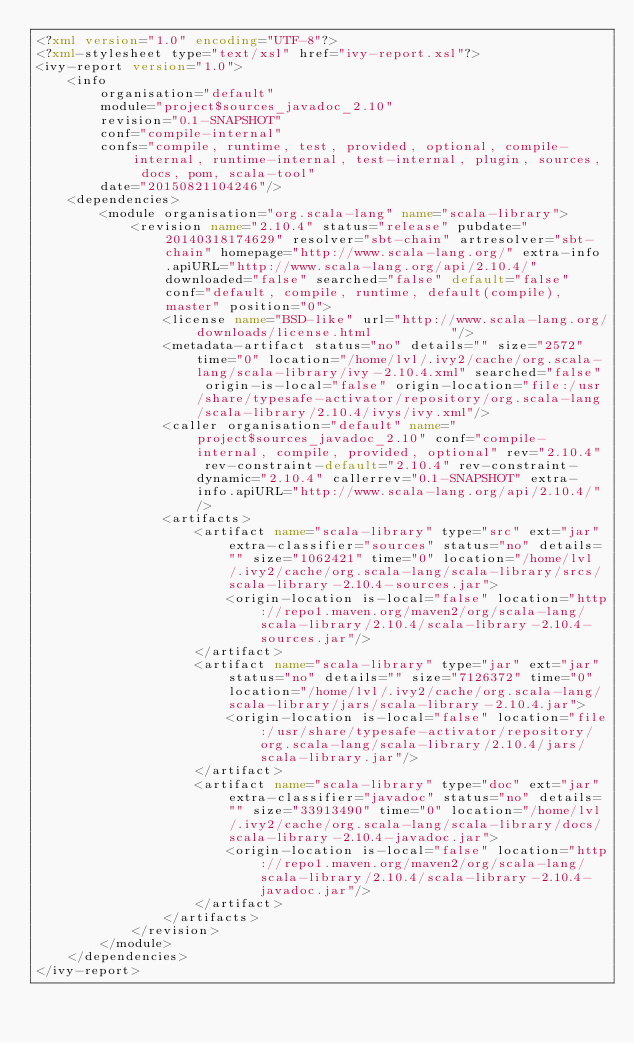<code> <loc_0><loc_0><loc_500><loc_500><_XML_><?xml version="1.0" encoding="UTF-8"?>
<?xml-stylesheet type="text/xsl" href="ivy-report.xsl"?>
<ivy-report version="1.0">
	<info
		organisation="default"
		module="project$sources_javadoc_2.10"
		revision="0.1-SNAPSHOT"
		conf="compile-internal"
		confs="compile, runtime, test, provided, optional, compile-internal, runtime-internal, test-internal, plugin, sources, docs, pom, scala-tool"
		date="20150821104246"/>
	<dependencies>
		<module organisation="org.scala-lang" name="scala-library">
			<revision name="2.10.4" status="release" pubdate="20140318174629" resolver="sbt-chain" artresolver="sbt-chain" homepage="http://www.scala-lang.org/" extra-info.apiURL="http://www.scala-lang.org/api/2.10.4/" downloaded="false" searched="false" default="false" conf="default, compile, runtime, default(compile), master" position="0">
				<license name="BSD-like" url="http://www.scala-lang.org/downloads/license.html          "/>
				<metadata-artifact status="no" details="" size="2572" time="0" location="/home/lvl/.ivy2/cache/org.scala-lang/scala-library/ivy-2.10.4.xml" searched="false" origin-is-local="false" origin-location="file:/usr/share/typesafe-activator/repository/org.scala-lang/scala-library/2.10.4/ivys/ivy.xml"/>
				<caller organisation="default" name="project$sources_javadoc_2.10" conf="compile-internal, compile, provided, optional" rev="2.10.4" rev-constraint-default="2.10.4" rev-constraint-dynamic="2.10.4" callerrev="0.1-SNAPSHOT" extra-info.apiURL="http://www.scala-lang.org/api/2.10.4/"/>
				<artifacts>
					<artifact name="scala-library" type="src" ext="jar" extra-classifier="sources" status="no" details="" size="1062421" time="0" location="/home/lvl/.ivy2/cache/org.scala-lang/scala-library/srcs/scala-library-2.10.4-sources.jar">
						<origin-location is-local="false" location="http://repo1.maven.org/maven2/org/scala-lang/scala-library/2.10.4/scala-library-2.10.4-sources.jar"/>
					</artifact>
					<artifact name="scala-library" type="jar" ext="jar" status="no" details="" size="7126372" time="0" location="/home/lvl/.ivy2/cache/org.scala-lang/scala-library/jars/scala-library-2.10.4.jar">
						<origin-location is-local="false" location="file:/usr/share/typesafe-activator/repository/org.scala-lang/scala-library/2.10.4/jars/scala-library.jar"/>
					</artifact>
					<artifact name="scala-library" type="doc" ext="jar" extra-classifier="javadoc" status="no" details="" size="33913490" time="0" location="/home/lvl/.ivy2/cache/org.scala-lang/scala-library/docs/scala-library-2.10.4-javadoc.jar">
						<origin-location is-local="false" location="http://repo1.maven.org/maven2/org/scala-lang/scala-library/2.10.4/scala-library-2.10.4-javadoc.jar"/>
					</artifact>
				</artifacts>
			</revision>
		</module>
	</dependencies>
</ivy-report>
</code> 